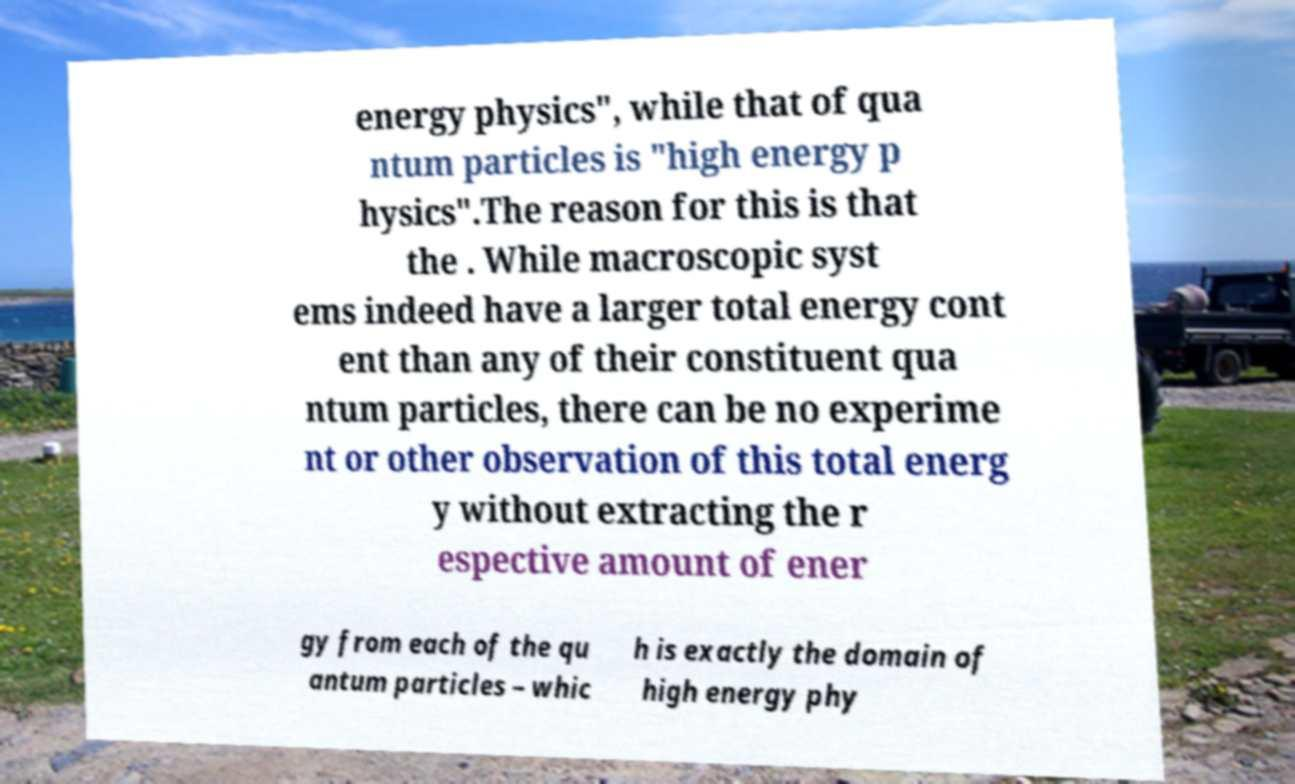Can you accurately transcribe the text from the provided image for me? energy physics", while that of qua ntum particles is "high energy p hysics".The reason for this is that the . While macroscopic syst ems indeed have a larger total energy cont ent than any of their constituent qua ntum particles, there can be no experime nt or other observation of this total energ y without extracting the r espective amount of ener gy from each of the qu antum particles – whic h is exactly the domain of high energy phy 